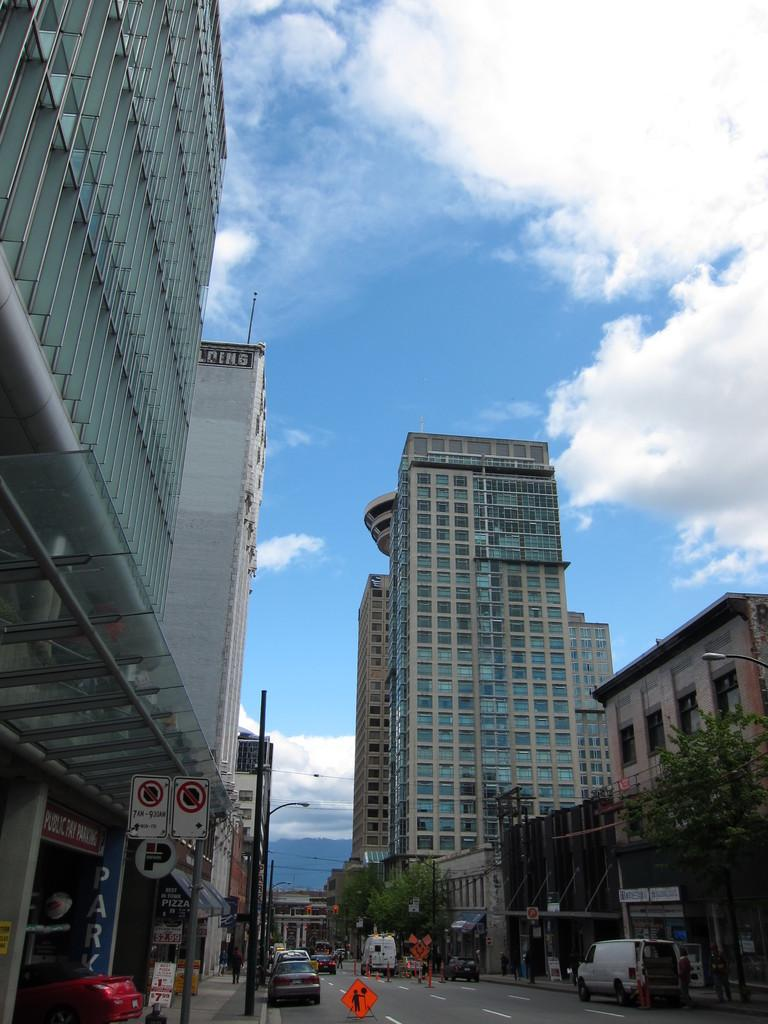What can be seen in the image? There is a group of vehicles in the image. What is placed on the road in the image? Traffic cones are placed on the road in the image. What can be seen in the background of the image? There are buildings, trees, and sign boards visible in the background of the image. How is the sky depicted in the image? The sky is cloudy in the background of the image. What type of paste is being used to hold the linen together in the image? There is no paste or linen present in the image; it features a group of vehicles, traffic cones, buildings, trees, sign boards, and a cloudy sky. Is there a stream visible in the image? No, there is no stream present in the image. 